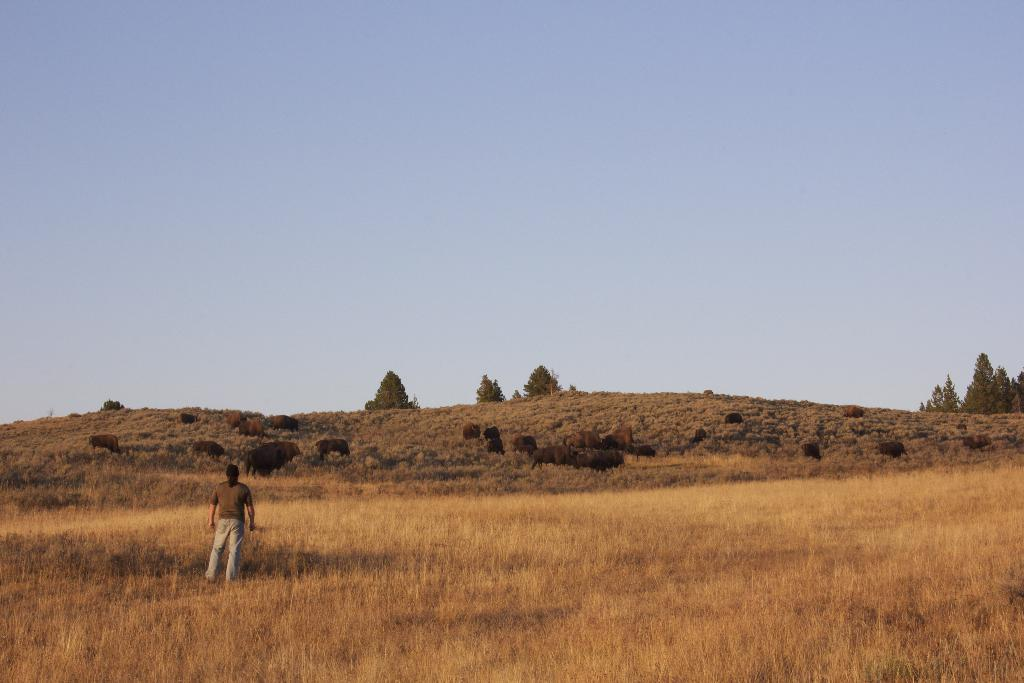What type of animals can be seen in the image? There is a group of animals on the grass in the image. Can you describe the person in the image? There is a person standing in the image. What is located in the middle of the image? Trees are visible in the middle of the image. What is visible at the top of the image? The sky is visible at the top of the image. What type of sticks can be seen in the image? There are no sticks present in the image. Can you describe the church in the image? There is no church present in the image. 